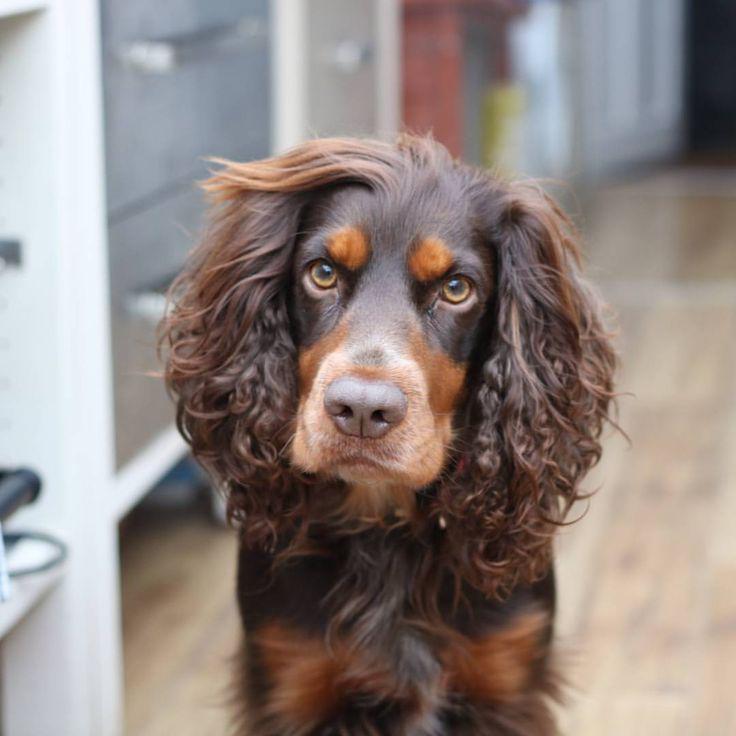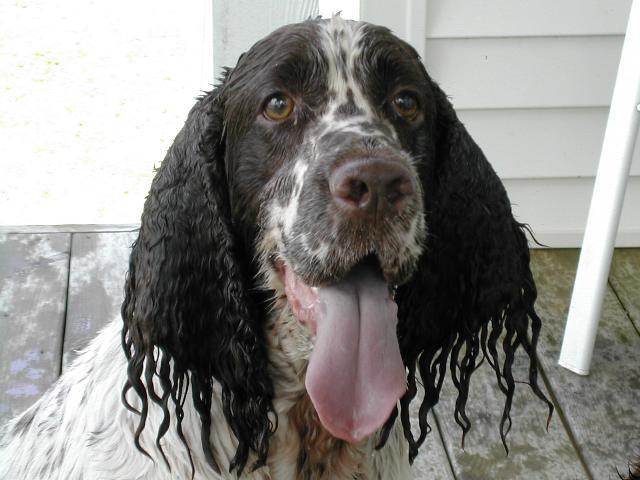The first image is the image on the left, the second image is the image on the right. Analyze the images presented: Is the assertion "The dog on the right has a charm dangling from its collar, and the dog on the left is sitting upright outdoors with something around its neck." valid? Answer yes or no. No. The first image is the image on the left, the second image is the image on the right. Considering the images on both sides, is "At least one dog is wearing a dog tag on its collar." valid? Answer yes or no. No. 